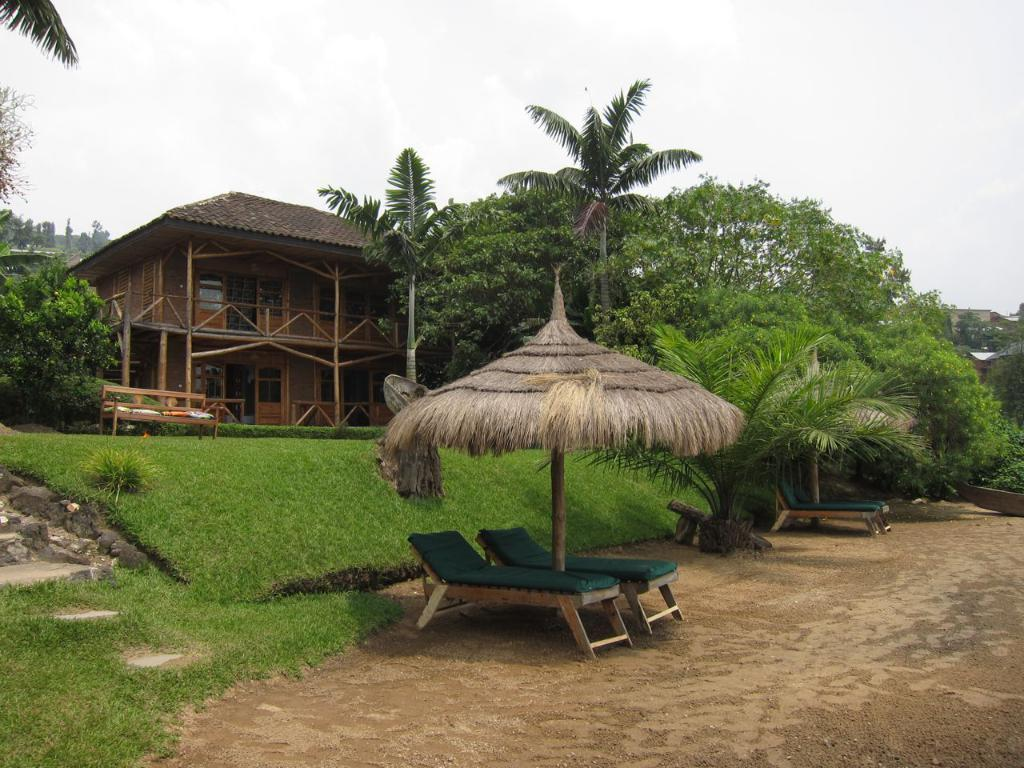What type of structure is present in the image? There is an umbrella hut in the image. What type of seating is available on the ground? Chairs are present on the ground. What other type of seating is available in the image? There is a bench in the image. What type of natural environment is visible in the image? Grass and trees are visible in the image. What type of man-made structure is visible in the image? There is a building in the image. What other type of man-made structures are visible in the image? Sheds are visible in the image. What is visible in the background of the image? The sky is visible in the background of the image. How many curves can be seen in the image? There is no specific mention of curves in the image, so it is not possible to determine the number of curves present. What type of bubble is visible in the image? There is no bubble present in the image. 